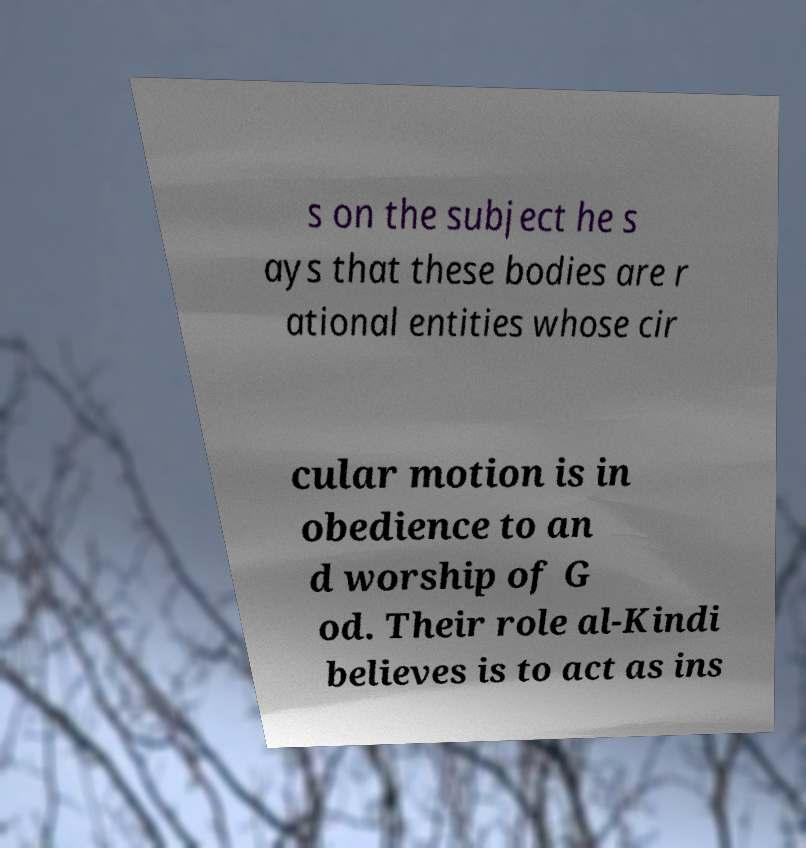Please read and relay the text visible in this image. What does it say? s on the subject he s ays that these bodies are r ational entities whose cir cular motion is in obedience to an d worship of G od. Their role al-Kindi believes is to act as ins 